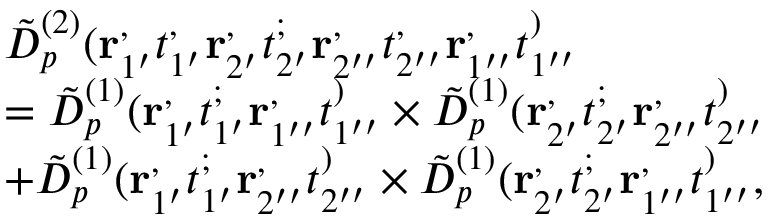<formula> <loc_0><loc_0><loc_500><loc_500>\begin{array} { r l } & { \tilde { D } _ { p } ^ { ( 2 ) } ( r _ { 1 ^ { \prime } } ^ { , } t _ { 1 ^ { \prime } } ^ { , } r _ { 2 ^ { \prime } } ^ { , } t _ { 2 ^ { \prime } } ^ { ; } r _ { 2 ^ { \prime \prime } } ^ { , } t _ { 2 ^ { \prime \prime } } ^ { , } r _ { 1 ^ { \prime \prime } } ^ { , } t _ { 1 ^ { \prime \prime } } ^ { ) } } \\ & { = \tilde { D } _ { p } ^ { ( 1 ) } ( r _ { 1 ^ { \prime } } ^ { , } t _ { 1 ^ { \prime } } ^ { ; } r _ { 1 ^ { \prime \prime } } ^ { , } t _ { 1 ^ { \prime \prime } } ^ { ) } \times \tilde { D } _ { p } ^ { ( 1 ) } ( r _ { 2 ^ { \prime } } ^ { , } t _ { 2 ^ { \prime } } ^ { ; } r _ { 2 ^ { \prime \prime } } ^ { , } t _ { 2 ^ { \prime \prime } } ^ { ) } } \\ & { + \tilde { D } _ { p } ^ { ( 1 ) } ( r _ { 1 ^ { \prime } } ^ { , } t _ { 1 ^ { \prime } } ^ { ; } r _ { 2 ^ { \prime \prime } } ^ { , } t _ { 2 ^ { \prime \prime } } ^ { ) } \times \tilde { D } _ { p } ^ { ( 1 ) } ( r _ { 2 ^ { \prime } } ^ { , } t _ { 2 ^ { \prime } } ^ { ; } r _ { 1 ^ { \prime \prime } } ^ { , } t _ { 1 ^ { \prime \prime } } ^ { ) } , } \end{array}</formula> 